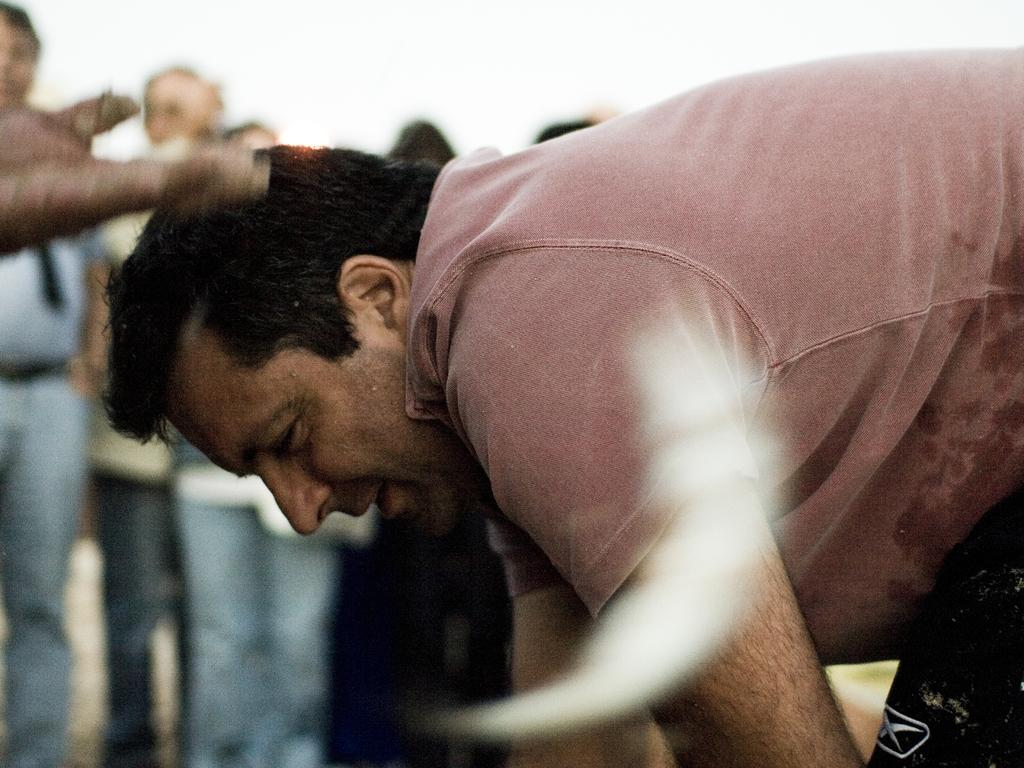What is the position of the man in the image? The man is on the right side of the image. What is the man wearing in the image? The man is wearing a t-shirt. What is the man doing in the image? The man is bending. Can you describe the people in the background of the image? There are people standing in the background of the image. What type of jar is visible on the left side of the image? There is no jar present on the left side of the image. What kind of cable can be seen connecting the man to the truck in the image? There is no truck or cable present in the image; it only features a man bending on the right side and people standing in the background. 